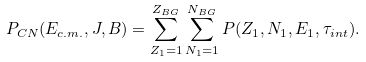Convert formula to latex. <formula><loc_0><loc_0><loc_500><loc_500>P _ { C N } ( E _ { c . m . } , J , B ) = \sum _ { Z _ { 1 } = 1 } ^ { Z _ { B G } } \sum _ { N _ { 1 } = 1 } ^ { N _ { B G } } P ( Z _ { 1 } , N _ { 1 } , E _ { 1 } , \tau _ { i n t } ) .</formula> 